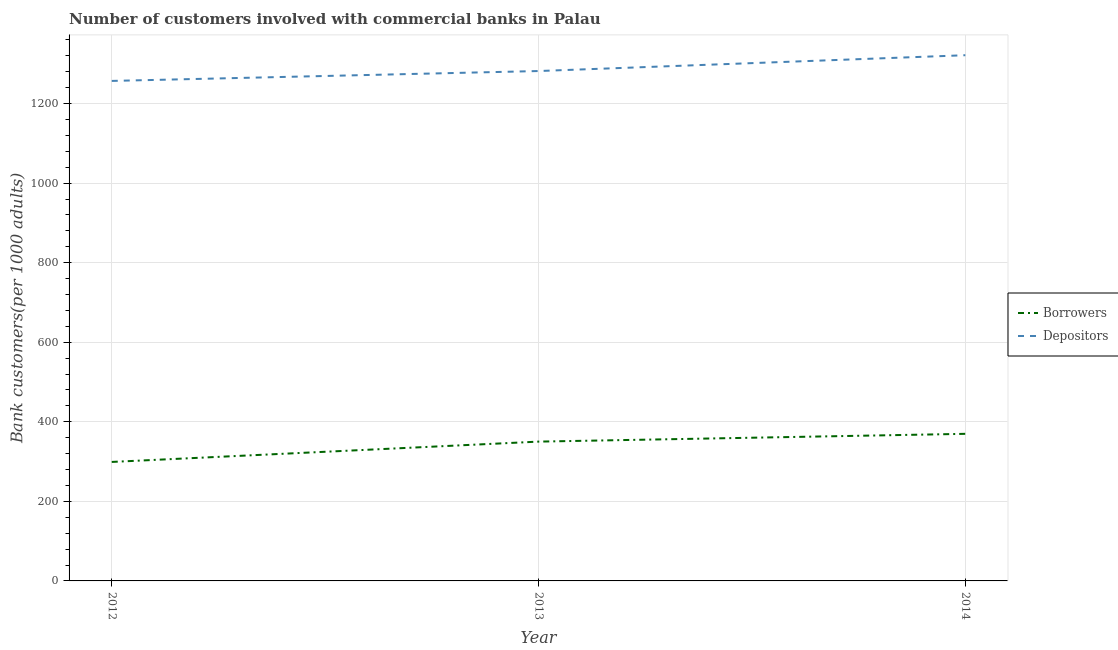How many different coloured lines are there?
Your answer should be very brief. 2. What is the number of depositors in 2014?
Make the answer very short. 1321.48. Across all years, what is the maximum number of borrowers?
Your answer should be compact. 369.74. Across all years, what is the minimum number of depositors?
Give a very brief answer. 1256.86. In which year was the number of borrowers maximum?
Your answer should be compact. 2014. In which year was the number of borrowers minimum?
Provide a succinct answer. 2012. What is the total number of borrowers in the graph?
Your answer should be compact. 1019.02. What is the difference between the number of depositors in 2012 and that in 2014?
Offer a terse response. -64.63. What is the difference between the number of depositors in 2012 and the number of borrowers in 2014?
Your answer should be very brief. 887.12. What is the average number of borrowers per year?
Ensure brevity in your answer.  339.67. In the year 2014, what is the difference between the number of borrowers and number of depositors?
Offer a terse response. -951.75. In how many years, is the number of borrowers greater than 320?
Offer a terse response. 2. What is the ratio of the number of depositors in 2012 to that in 2013?
Provide a short and direct response. 0.98. Is the difference between the number of borrowers in 2012 and 2013 greater than the difference between the number of depositors in 2012 and 2013?
Keep it short and to the point. No. What is the difference between the highest and the second highest number of borrowers?
Keep it short and to the point. 19.56. What is the difference between the highest and the lowest number of depositors?
Your answer should be compact. 64.63. Is the sum of the number of borrowers in 2012 and 2013 greater than the maximum number of depositors across all years?
Make the answer very short. No. Does the number of borrowers monotonically increase over the years?
Your response must be concise. Yes. Is the number of depositors strictly less than the number of borrowers over the years?
Your response must be concise. No. How many lines are there?
Give a very brief answer. 2. How many years are there in the graph?
Keep it short and to the point. 3. What is the difference between two consecutive major ticks on the Y-axis?
Offer a terse response. 200. Are the values on the major ticks of Y-axis written in scientific E-notation?
Provide a succinct answer. No. Does the graph contain any zero values?
Provide a short and direct response. No. Does the graph contain grids?
Your response must be concise. Yes. What is the title of the graph?
Keep it short and to the point. Number of customers involved with commercial banks in Palau. Does "Chemicals" appear as one of the legend labels in the graph?
Your response must be concise. No. What is the label or title of the Y-axis?
Keep it short and to the point. Bank customers(per 1000 adults). What is the Bank customers(per 1000 adults) of Borrowers in 2012?
Make the answer very short. 299.11. What is the Bank customers(per 1000 adults) in Depositors in 2012?
Make the answer very short. 1256.86. What is the Bank customers(per 1000 adults) in Borrowers in 2013?
Your response must be concise. 350.18. What is the Bank customers(per 1000 adults) of Depositors in 2013?
Ensure brevity in your answer.  1281.71. What is the Bank customers(per 1000 adults) in Borrowers in 2014?
Provide a succinct answer. 369.74. What is the Bank customers(per 1000 adults) of Depositors in 2014?
Provide a short and direct response. 1321.48. Across all years, what is the maximum Bank customers(per 1000 adults) in Borrowers?
Provide a short and direct response. 369.74. Across all years, what is the maximum Bank customers(per 1000 adults) of Depositors?
Your answer should be compact. 1321.48. Across all years, what is the minimum Bank customers(per 1000 adults) in Borrowers?
Make the answer very short. 299.11. Across all years, what is the minimum Bank customers(per 1000 adults) in Depositors?
Your answer should be very brief. 1256.86. What is the total Bank customers(per 1000 adults) of Borrowers in the graph?
Your response must be concise. 1019.02. What is the total Bank customers(per 1000 adults) in Depositors in the graph?
Your answer should be very brief. 3860.05. What is the difference between the Bank customers(per 1000 adults) of Borrowers in 2012 and that in 2013?
Keep it short and to the point. -51.07. What is the difference between the Bank customers(per 1000 adults) in Depositors in 2012 and that in 2013?
Provide a succinct answer. -24.86. What is the difference between the Bank customers(per 1000 adults) in Borrowers in 2012 and that in 2014?
Give a very brief answer. -70.63. What is the difference between the Bank customers(per 1000 adults) of Depositors in 2012 and that in 2014?
Your response must be concise. -64.63. What is the difference between the Bank customers(per 1000 adults) of Borrowers in 2013 and that in 2014?
Your answer should be very brief. -19.56. What is the difference between the Bank customers(per 1000 adults) of Depositors in 2013 and that in 2014?
Your answer should be compact. -39.77. What is the difference between the Bank customers(per 1000 adults) of Borrowers in 2012 and the Bank customers(per 1000 adults) of Depositors in 2013?
Ensure brevity in your answer.  -982.61. What is the difference between the Bank customers(per 1000 adults) of Borrowers in 2012 and the Bank customers(per 1000 adults) of Depositors in 2014?
Offer a very short reply. -1022.38. What is the difference between the Bank customers(per 1000 adults) in Borrowers in 2013 and the Bank customers(per 1000 adults) in Depositors in 2014?
Provide a succinct answer. -971.3. What is the average Bank customers(per 1000 adults) in Borrowers per year?
Make the answer very short. 339.67. What is the average Bank customers(per 1000 adults) of Depositors per year?
Your answer should be compact. 1286.68. In the year 2012, what is the difference between the Bank customers(per 1000 adults) in Borrowers and Bank customers(per 1000 adults) in Depositors?
Your answer should be very brief. -957.75. In the year 2013, what is the difference between the Bank customers(per 1000 adults) in Borrowers and Bank customers(per 1000 adults) in Depositors?
Give a very brief answer. -931.53. In the year 2014, what is the difference between the Bank customers(per 1000 adults) of Borrowers and Bank customers(per 1000 adults) of Depositors?
Provide a short and direct response. -951.75. What is the ratio of the Bank customers(per 1000 adults) in Borrowers in 2012 to that in 2013?
Make the answer very short. 0.85. What is the ratio of the Bank customers(per 1000 adults) in Depositors in 2012 to that in 2013?
Keep it short and to the point. 0.98. What is the ratio of the Bank customers(per 1000 adults) in Borrowers in 2012 to that in 2014?
Your answer should be compact. 0.81. What is the ratio of the Bank customers(per 1000 adults) in Depositors in 2012 to that in 2014?
Your answer should be compact. 0.95. What is the ratio of the Bank customers(per 1000 adults) in Borrowers in 2013 to that in 2014?
Provide a short and direct response. 0.95. What is the ratio of the Bank customers(per 1000 adults) of Depositors in 2013 to that in 2014?
Your answer should be compact. 0.97. What is the difference between the highest and the second highest Bank customers(per 1000 adults) of Borrowers?
Your answer should be compact. 19.56. What is the difference between the highest and the second highest Bank customers(per 1000 adults) of Depositors?
Give a very brief answer. 39.77. What is the difference between the highest and the lowest Bank customers(per 1000 adults) in Borrowers?
Provide a short and direct response. 70.63. What is the difference between the highest and the lowest Bank customers(per 1000 adults) of Depositors?
Your answer should be very brief. 64.63. 